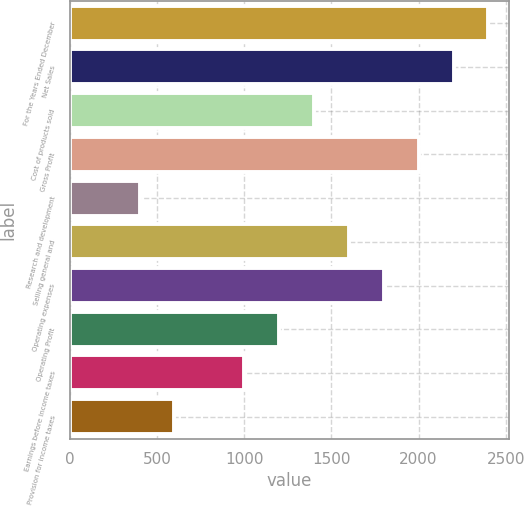Convert chart. <chart><loc_0><loc_0><loc_500><loc_500><bar_chart><fcel>For the Years Ended December<fcel>Net Sales<fcel>Cost of products sold<fcel>Gross Profit<fcel>Research and development<fcel>Selling general and<fcel>Operating expenses<fcel>Operating Profit<fcel>Earnings before income taxes<fcel>Provision for income taxes<nl><fcel>2401.01<fcel>2200.99<fcel>1400.91<fcel>2000.97<fcel>400.81<fcel>1600.93<fcel>1800.95<fcel>1200.89<fcel>1000.87<fcel>600.83<nl></chart> 